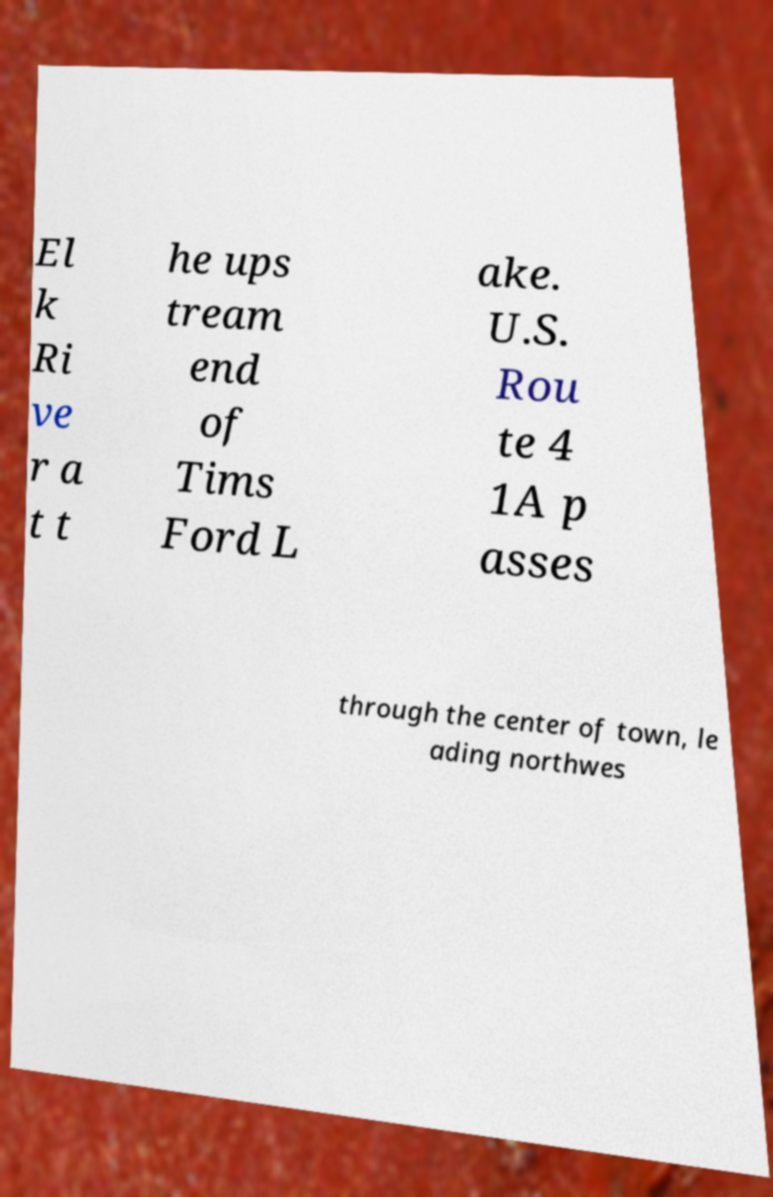Can you read and provide the text displayed in the image?This photo seems to have some interesting text. Can you extract and type it out for me? El k Ri ve r a t t he ups tream end of Tims Ford L ake. U.S. Rou te 4 1A p asses through the center of town, le ading northwes 